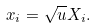Convert formula to latex. <formula><loc_0><loc_0><loc_500><loc_500>x _ { i } = \sqrt { u } X _ { i } .</formula> 